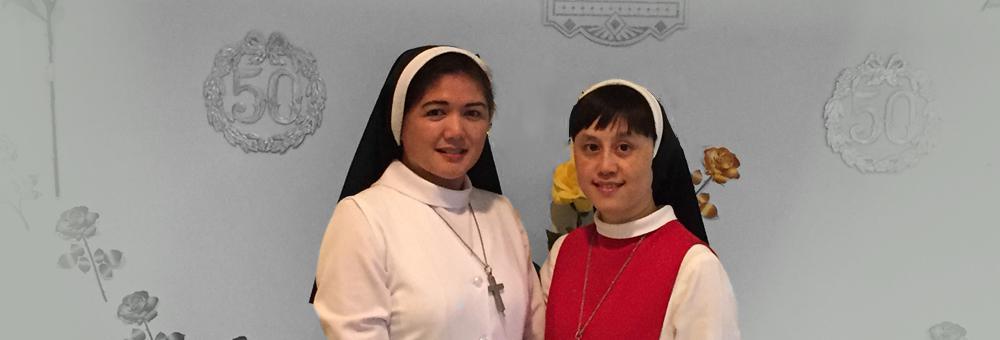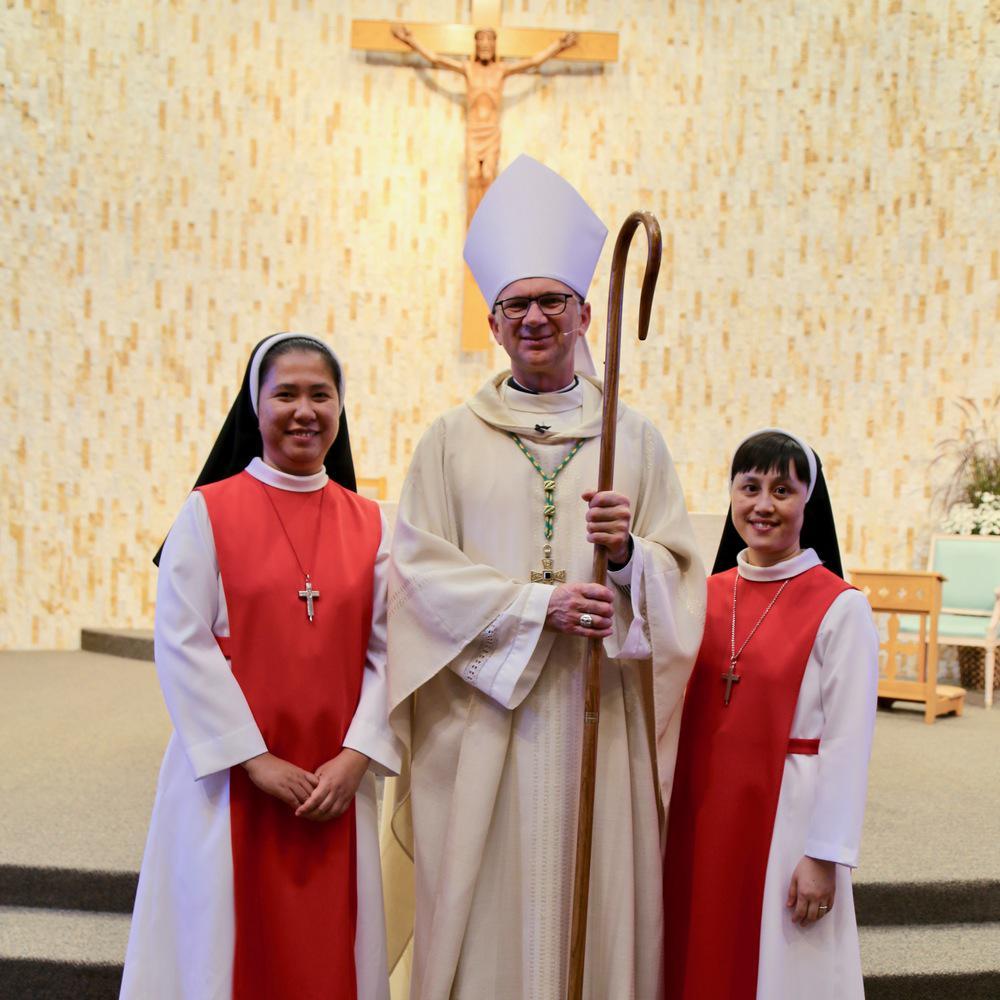The first image is the image on the left, the second image is the image on the right. For the images shown, is this caption "Each image includes a woman wearing red and white and a woman wearing a black-and-white head covering, and the left image contains two people, while the right image contains three people." true? Answer yes or no. Yes. The first image is the image on the left, the second image is the image on the right. Considering the images on both sides, is "There are women and no men." valid? Answer yes or no. No. 